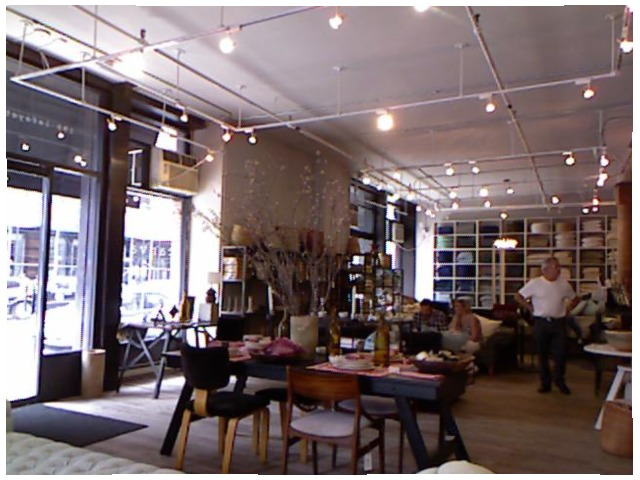<image>
Can you confirm if the table is behind the chair? Yes. From this viewpoint, the table is positioned behind the chair, with the chair partially or fully occluding the table. Is there a light above the chair? Yes. The light is positioned above the chair in the vertical space, higher up in the scene. 